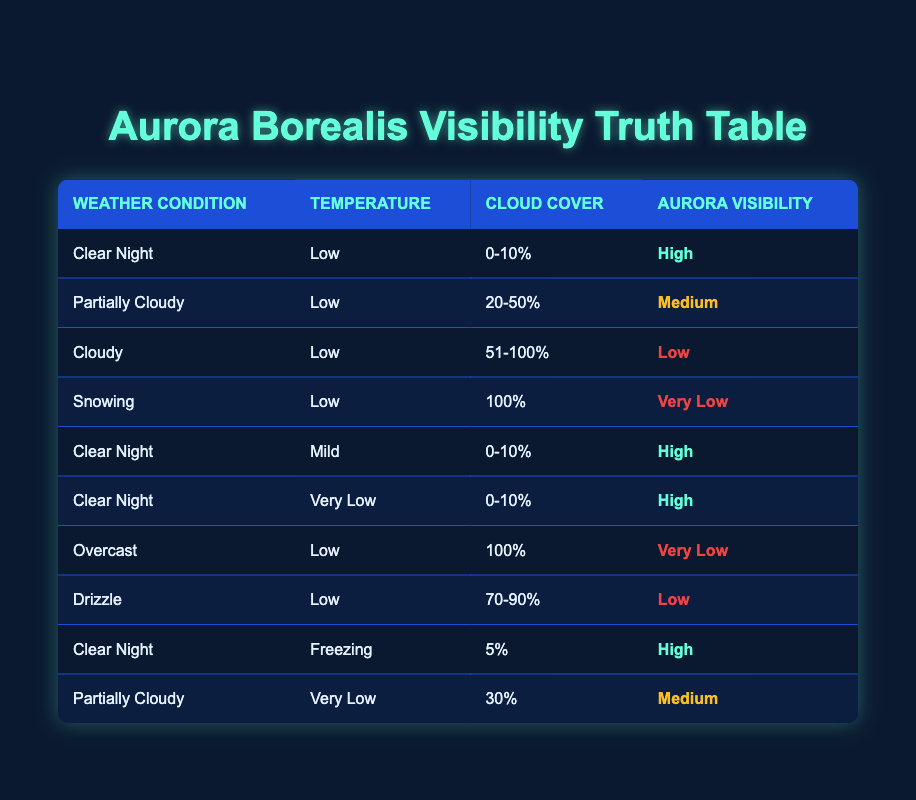What is the aurora visibility when the weather condition is "Clear Night" and the temperature is "Low"? The table shows that under the weather condition "Clear Night" with a temperature of "Low", the aurora visibility is "High".
Answer: High How many weather conditions result in "Very Low" aurora visibility? There are two weather conditions resulting in "Very Low" aurora visibility: "Snowing" and "Overcast".
Answer: 2 Which temperature condition has only high aurora visibility listed? The temperature conditions that have only "High" aurora visibility listed are "Low", "Mild", "Very Low", and "Freezing" during "Clear Night". The absence of other records implies that only "Clear Night" at those temperatures results in "High" visibility.
Answer: Low, Mild, Very Low, Freezing Is there any weather condition with a "Medium" aurora visibility that also has a cloud cover of less than 50%? Yes, "Partially Cloudy" at "Low" temperature with a cloud cover of "20-50%" has a "Medium" aurora visibility.
Answer: Yes What is the average cloud cover for weather conditions with "Medium" aurora visibility? The only rows with "Medium" aurora visibility are "Partially Cloudy" with cloud cover of "20-50%" and "Partially Cloudy" with cloud cover of "30%". To average these values, we consider the cloud cover: for "20-50%", we take the midpoint which is 35%. Therefore, the average cloud cover is (35% + 30%) / 2 = 32.5%.
Answer: 32.5% 